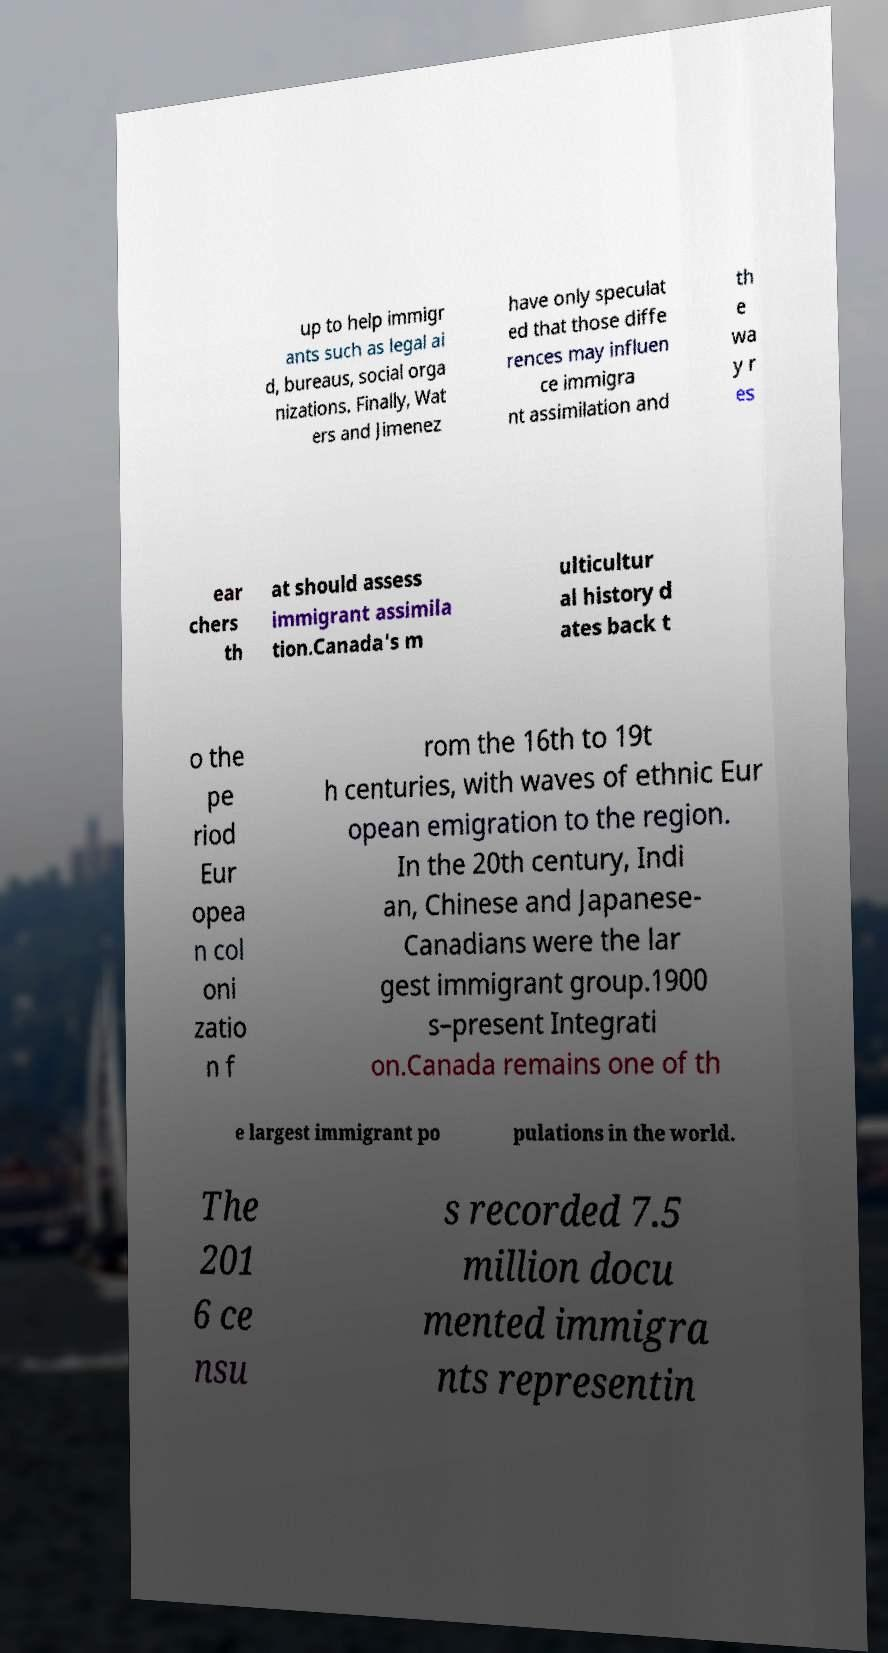I need the written content from this picture converted into text. Can you do that? up to help immigr ants such as legal ai d, bureaus, social orga nizations. Finally, Wat ers and Jimenez have only speculat ed that those diffe rences may influen ce immigra nt assimilation and th e wa y r es ear chers th at should assess immigrant assimila tion.Canada's m ulticultur al history d ates back t o the pe riod Eur opea n col oni zatio n f rom the 16th to 19t h centuries, with waves of ethnic Eur opean emigration to the region. In the 20th century, Indi an, Chinese and Japanese- Canadians were the lar gest immigrant group.1900 s–present Integrati on.Canada remains one of th e largest immigrant po pulations in the world. The 201 6 ce nsu s recorded 7.5 million docu mented immigra nts representin 